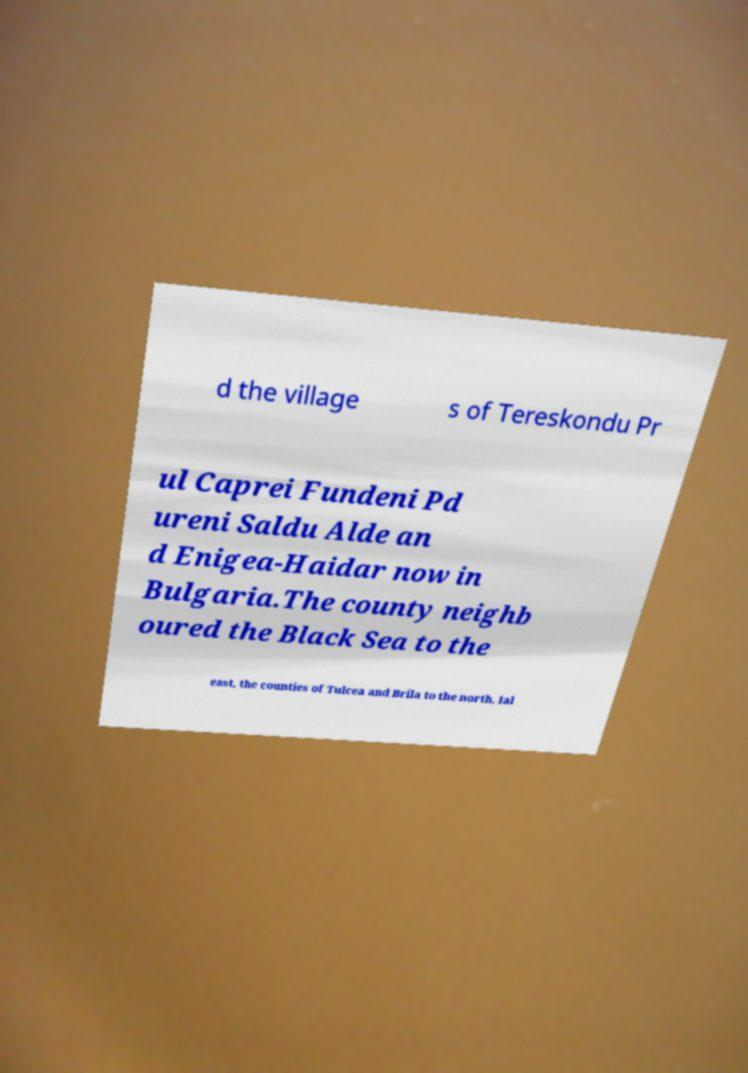I need the written content from this picture converted into text. Can you do that? d the village s of Tereskondu Pr ul Caprei Fundeni Pd ureni Saldu Alde an d Enigea-Haidar now in Bulgaria.The county neighb oured the Black Sea to the east, the counties of Tulcea and Brila to the north, Ial 